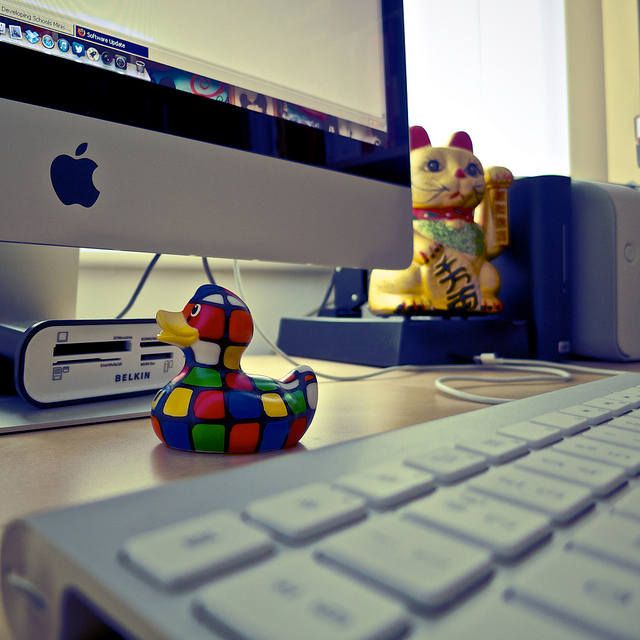Read and extract the text from this image. BELKIN Developers 